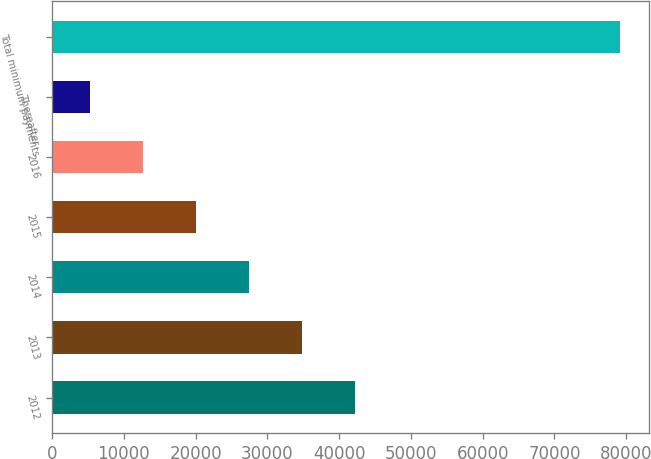Convert chart to OTSL. <chart><loc_0><loc_0><loc_500><loc_500><bar_chart><fcel>2012<fcel>2013<fcel>2014<fcel>2015<fcel>2016<fcel>Thereafter<fcel>Total minimum payments<nl><fcel>42259<fcel>34872.4<fcel>27485.8<fcel>20099.2<fcel>12712.6<fcel>5326<fcel>79192<nl></chart> 